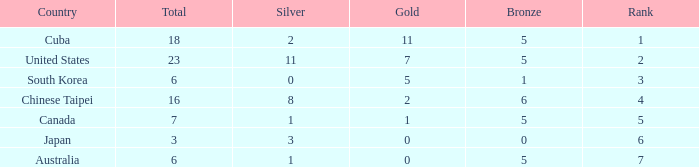What was the sum of the ranks for Japan who had less than 5 bronze medals and more than 3 silvers? None. 